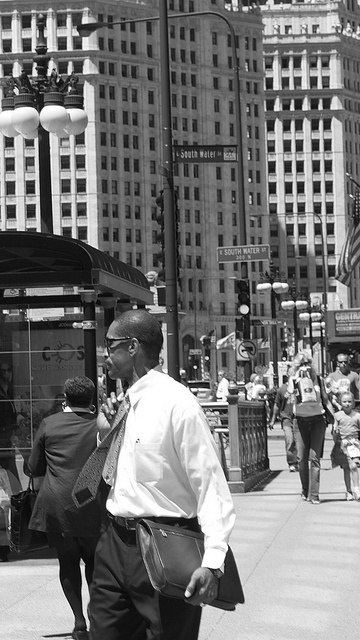Describe the objects in this image and their specific colors. I can see people in lightgray, white, black, gray, and darkgray tones, people in lightgray, black, gray, and darkgray tones, handbag in lightgray, gray, and black tones, tie in lightgray, gray, darkgray, and black tones, and people in lightgray, gainsboro, gray, darkgray, and black tones in this image. 